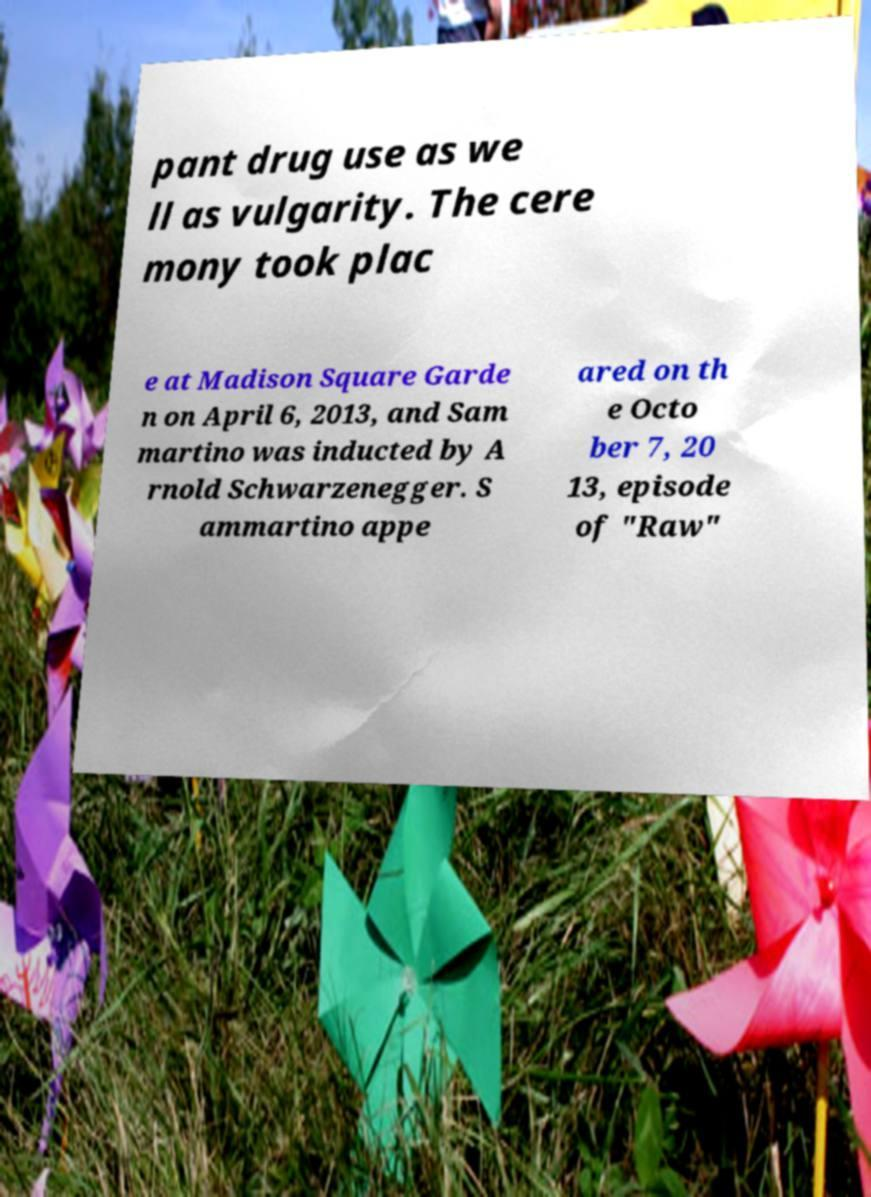There's text embedded in this image that I need extracted. Can you transcribe it verbatim? pant drug use as we ll as vulgarity. The cere mony took plac e at Madison Square Garde n on April 6, 2013, and Sam martino was inducted by A rnold Schwarzenegger. S ammartino appe ared on th e Octo ber 7, 20 13, episode of "Raw" 